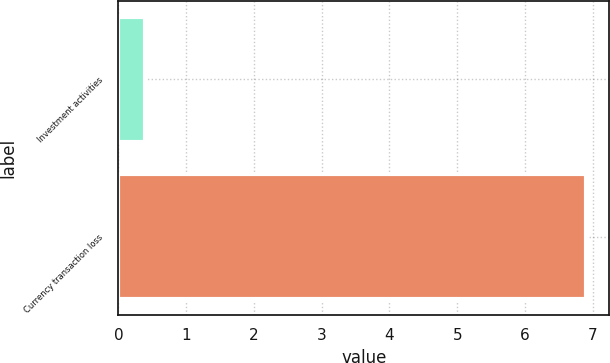Convert chart to OTSL. <chart><loc_0><loc_0><loc_500><loc_500><bar_chart><fcel>Investment activities<fcel>Currency transaction loss<nl><fcel>0.4<fcel>6.9<nl></chart> 